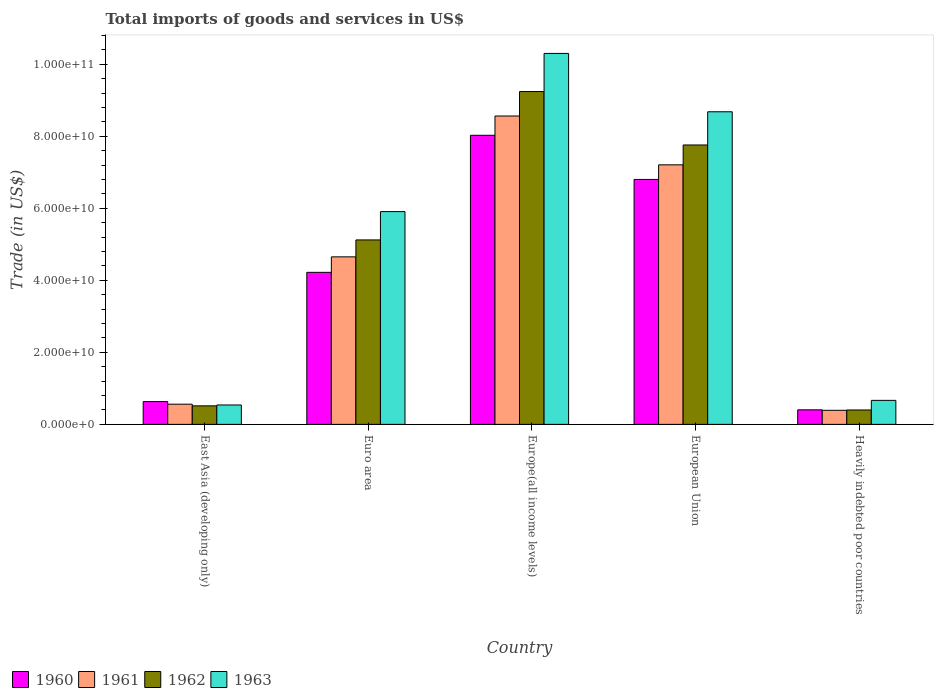How many different coloured bars are there?
Provide a short and direct response. 4. How many bars are there on the 2nd tick from the left?
Keep it short and to the point. 4. How many bars are there on the 5th tick from the right?
Offer a very short reply. 4. In how many cases, is the number of bars for a given country not equal to the number of legend labels?
Give a very brief answer. 0. What is the total imports of goods and services in 1961 in European Union?
Your answer should be very brief. 7.21e+1. Across all countries, what is the maximum total imports of goods and services in 1960?
Keep it short and to the point. 8.03e+1. Across all countries, what is the minimum total imports of goods and services in 1962?
Offer a very short reply. 4.00e+09. In which country was the total imports of goods and services in 1962 maximum?
Provide a short and direct response. Europe(all income levels). In which country was the total imports of goods and services in 1960 minimum?
Offer a terse response. Heavily indebted poor countries. What is the total total imports of goods and services in 1963 in the graph?
Ensure brevity in your answer.  2.61e+11. What is the difference between the total imports of goods and services in 1963 in East Asia (developing only) and that in Europe(all income levels)?
Your answer should be compact. -9.76e+1. What is the difference between the total imports of goods and services in 1962 in Euro area and the total imports of goods and services in 1961 in Heavily indebted poor countries?
Offer a very short reply. 4.73e+1. What is the average total imports of goods and services in 1961 per country?
Your response must be concise. 4.27e+1. What is the difference between the total imports of goods and services of/in 1960 and total imports of goods and services of/in 1961 in European Union?
Your response must be concise. -4.05e+09. What is the ratio of the total imports of goods and services in 1961 in East Asia (developing only) to that in European Union?
Provide a short and direct response. 0.08. Is the difference between the total imports of goods and services in 1960 in Europe(all income levels) and Heavily indebted poor countries greater than the difference between the total imports of goods and services in 1961 in Europe(all income levels) and Heavily indebted poor countries?
Your answer should be very brief. No. What is the difference between the highest and the second highest total imports of goods and services in 1963?
Provide a succinct answer. -1.62e+1. What is the difference between the highest and the lowest total imports of goods and services in 1963?
Give a very brief answer. 9.76e+1. Is the sum of the total imports of goods and services in 1962 in European Union and Heavily indebted poor countries greater than the maximum total imports of goods and services in 1963 across all countries?
Your response must be concise. No. What does the 2nd bar from the left in Europe(all income levels) represents?
Give a very brief answer. 1961. What does the 2nd bar from the right in European Union represents?
Your response must be concise. 1962. How many bars are there?
Give a very brief answer. 20. Are all the bars in the graph horizontal?
Give a very brief answer. No. How many countries are there in the graph?
Offer a very short reply. 5. What is the difference between two consecutive major ticks on the Y-axis?
Offer a very short reply. 2.00e+1. Does the graph contain any zero values?
Your answer should be compact. No. Does the graph contain grids?
Offer a very short reply. No. How many legend labels are there?
Your answer should be very brief. 4. How are the legend labels stacked?
Your answer should be very brief. Horizontal. What is the title of the graph?
Your response must be concise. Total imports of goods and services in US$. Does "1979" appear as one of the legend labels in the graph?
Provide a short and direct response. No. What is the label or title of the X-axis?
Your response must be concise. Country. What is the label or title of the Y-axis?
Your answer should be very brief. Trade (in US$). What is the Trade (in US$) of 1960 in East Asia (developing only)?
Make the answer very short. 6.33e+09. What is the Trade (in US$) of 1961 in East Asia (developing only)?
Provide a short and direct response. 5.60e+09. What is the Trade (in US$) in 1962 in East Asia (developing only)?
Offer a very short reply. 5.14e+09. What is the Trade (in US$) of 1963 in East Asia (developing only)?
Ensure brevity in your answer.  5.39e+09. What is the Trade (in US$) of 1960 in Euro area?
Offer a very short reply. 4.22e+1. What is the Trade (in US$) in 1961 in Euro area?
Keep it short and to the point. 4.65e+1. What is the Trade (in US$) in 1962 in Euro area?
Offer a very short reply. 5.12e+1. What is the Trade (in US$) of 1963 in Euro area?
Offer a terse response. 5.91e+1. What is the Trade (in US$) of 1960 in Europe(all income levels)?
Offer a very short reply. 8.03e+1. What is the Trade (in US$) in 1961 in Europe(all income levels)?
Ensure brevity in your answer.  8.56e+1. What is the Trade (in US$) of 1962 in Europe(all income levels)?
Offer a terse response. 9.24e+1. What is the Trade (in US$) of 1963 in Europe(all income levels)?
Offer a terse response. 1.03e+11. What is the Trade (in US$) in 1960 in European Union?
Your response must be concise. 6.80e+1. What is the Trade (in US$) of 1961 in European Union?
Provide a succinct answer. 7.21e+1. What is the Trade (in US$) of 1962 in European Union?
Give a very brief answer. 7.76e+1. What is the Trade (in US$) in 1963 in European Union?
Your answer should be very brief. 8.68e+1. What is the Trade (in US$) of 1960 in Heavily indebted poor countries?
Give a very brief answer. 4.04e+09. What is the Trade (in US$) of 1961 in Heavily indebted poor countries?
Offer a very short reply. 3.91e+09. What is the Trade (in US$) of 1962 in Heavily indebted poor countries?
Your answer should be compact. 4.00e+09. What is the Trade (in US$) in 1963 in Heavily indebted poor countries?
Make the answer very short. 6.67e+09. Across all countries, what is the maximum Trade (in US$) of 1960?
Offer a very short reply. 8.03e+1. Across all countries, what is the maximum Trade (in US$) of 1961?
Give a very brief answer. 8.56e+1. Across all countries, what is the maximum Trade (in US$) of 1962?
Ensure brevity in your answer.  9.24e+1. Across all countries, what is the maximum Trade (in US$) in 1963?
Your answer should be very brief. 1.03e+11. Across all countries, what is the minimum Trade (in US$) in 1960?
Your answer should be very brief. 4.04e+09. Across all countries, what is the minimum Trade (in US$) of 1961?
Ensure brevity in your answer.  3.91e+09. Across all countries, what is the minimum Trade (in US$) in 1962?
Provide a short and direct response. 4.00e+09. Across all countries, what is the minimum Trade (in US$) of 1963?
Provide a succinct answer. 5.39e+09. What is the total Trade (in US$) in 1960 in the graph?
Offer a terse response. 2.01e+11. What is the total Trade (in US$) in 1961 in the graph?
Keep it short and to the point. 2.14e+11. What is the total Trade (in US$) in 1962 in the graph?
Provide a short and direct response. 2.30e+11. What is the total Trade (in US$) in 1963 in the graph?
Provide a short and direct response. 2.61e+11. What is the difference between the Trade (in US$) of 1960 in East Asia (developing only) and that in Euro area?
Offer a terse response. -3.59e+1. What is the difference between the Trade (in US$) in 1961 in East Asia (developing only) and that in Euro area?
Make the answer very short. -4.09e+1. What is the difference between the Trade (in US$) in 1962 in East Asia (developing only) and that in Euro area?
Your answer should be very brief. -4.61e+1. What is the difference between the Trade (in US$) of 1963 in East Asia (developing only) and that in Euro area?
Your response must be concise. -5.37e+1. What is the difference between the Trade (in US$) in 1960 in East Asia (developing only) and that in Europe(all income levels)?
Your answer should be very brief. -7.39e+1. What is the difference between the Trade (in US$) in 1961 in East Asia (developing only) and that in Europe(all income levels)?
Offer a very short reply. -8.00e+1. What is the difference between the Trade (in US$) in 1962 in East Asia (developing only) and that in Europe(all income levels)?
Your answer should be very brief. -8.73e+1. What is the difference between the Trade (in US$) of 1963 in East Asia (developing only) and that in Europe(all income levels)?
Your answer should be very brief. -9.76e+1. What is the difference between the Trade (in US$) of 1960 in East Asia (developing only) and that in European Union?
Your answer should be compact. -6.17e+1. What is the difference between the Trade (in US$) of 1961 in East Asia (developing only) and that in European Union?
Provide a succinct answer. -6.65e+1. What is the difference between the Trade (in US$) in 1962 in East Asia (developing only) and that in European Union?
Offer a very short reply. -7.24e+1. What is the difference between the Trade (in US$) of 1963 in East Asia (developing only) and that in European Union?
Your answer should be very brief. -8.14e+1. What is the difference between the Trade (in US$) in 1960 in East Asia (developing only) and that in Heavily indebted poor countries?
Give a very brief answer. 2.29e+09. What is the difference between the Trade (in US$) of 1961 in East Asia (developing only) and that in Heavily indebted poor countries?
Provide a short and direct response. 1.70e+09. What is the difference between the Trade (in US$) of 1962 in East Asia (developing only) and that in Heavily indebted poor countries?
Offer a terse response. 1.14e+09. What is the difference between the Trade (in US$) of 1963 in East Asia (developing only) and that in Heavily indebted poor countries?
Keep it short and to the point. -1.28e+09. What is the difference between the Trade (in US$) of 1960 in Euro area and that in Europe(all income levels)?
Keep it short and to the point. -3.80e+1. What is the difference between the Trade (in US$) in 1961 in Euro area and that in Europe(all income levels)?
Provide a short and direct response. -3.91e+1. What is the difference between the Trade (in US$) in 1962 in Euro area and that in Europe(all income levels)?
Your response must be concise. -4.12e+1. What is the difference between the Trade (in US$) of 1963 in Euro area and that in Europe(all income levels)?
Offer a terse response. -4.39e+1. What is the difference between the Trade (in US$) in 1960 in Euro area and that in European Union?
Offer a terse response. -2.58e+1. What is the difference between the Trade (in US$) of 1961 in Euro area and that in European Union?
Provide a succinct answer. -2.56e+1. What is the difference between the Trade (in US$) in 1962 in Euro area and that in European Union?
Provide a short and direct response. -2.64e+1. What is the difference between the Trade (in US$) in 1963 in Euro area and that in European Union?
Offer a very short reply. -2.77e+1. What is the difference between the Trade (in US$) in 1960 in Euro area and that in Heavily indebted poor countries?
Offer a very short reply. 3.82e+1. What is the difference between the Trade (in US$) of 1961 in Euro area and that in Heavily indebted poor countries?
Your response must be concise. 4.26e+1. What is the difference between the Trade (in US$) in 1962 in Euro area and that in Heavily indebted poor countries?
Your answer should be very brief. 4.72e+1. What is the difference between the Trade (in US$) in 1963 in Euro area and that in Heavily indebted poor countries?
Offer a terse response. 5.24e+1. What is the difference between the Trade (in US$) in 1960 in Europe(all income levels) and that in European Union?
Ensure brevity in your answer.  1.23e+1. What is the difference between the Trade (in US$) in 1961 in Europe(all income levels) and that in European Union?
Your response must be concise. 1.36e+1. What is the difference between the Trade (in US$) of 1962 in Europe(all income levels) and that in European Union?
Provide a short and direct response. 1.48e+1. What is the difference between the Trade (in US$) in 1963 in Europe(all income levels) and that in European Union?
Offer a very short reply. 1.62e+1. What is the difference between the Trade (in US$) of 1960 in Europe(all income levels) and that in Heavily indebted poor countries?
Provide a short and direct response. 7.62e+1. What is the difference between the Trade (in US$) of 1961 in Europe(all income levels) and that in Heavily indebted poor countries?
Provide a succinct answer. 8.17e+1. What is the difference between the Trade (in US$) of 1962 in Europe(all income levels) and that in Heavily indebted poor countries?
Your answer should be compact. 8.84e+1. What is the difference between the Trade (in US$) of 1963 in Europe(all income levels) and that in Heavily indebted poor countries?
Ensure brevity in your answer.  9.63e+1. What is the difference between the Trade (in US$) of 1960 in European Union and that in Heavily indebted poor countries?
Give a very brief answer. 6.40e+1. What is the difference between the Trade (in US$) of 1961 in European Union and that in Heavily indebted poor countries?
Your response must be concise. 6.82e+1. What is the difference between the Trade (in US$) in 1962 in European Union and that in Heavily indebted poor countries?
Provide a succinct answer. 7.36e+1. What is the difference between the Trade (in US$) in 1963 in European Union and that in Heavily indebted poor countries?
Make the answer very short. 8.01e+1. What is the difference between the Trade (in US$) of 1960 in East Asia (developing only) and the Trade (in US$) of 1961 in Euro area?
Provide a short and direct response. -4.02e+1. What is the difference between the Trade (in US$) of 1960 in East Asia (developing only) and the Trade (in US$) of 1962 in Euro area?
Ensure brevity in your answer.  -4.49e+1. What is the difference between the Trade (in US$) of 1960 in East Asia (developing only) and the Trade (in US$) of 1963 in Euro area?
Your answer should be compact. -5.27e+1. What is the difference between the Trade (in US$) of 1961 in East Asia (developing only) and the Trade (in US$) of 1962 in Euro area?
Provide a short and direct response. -4.56e+1. What is the difference between the Trade (in US$) in 1961 in East Asia (developing only) and the Trade (in US$) in 1963 in Euro area?
Offer a terse response. -5.35e+1. What is the difference between the Trade (in US$) in 1962 in East Asia (developing only) and the Trade (in US$) in 1963 in Euro area?
Ensure brevity in your answer.  -5.39e+1. What is the difference between the Trade (in US$) in 1960 in East Asia (developing only) and the Trade (in US$) in 1961 in Europe(all income levels)?
Offer a very short reply. -7.93e+1. What is the difference between the Trade (in US$) of 1960 in East Asia (developing only) and the Trade (in US$) of 1962 in Europe(all income levels)?
Ensure brevity in your answer.  -8.61e+1. What is the difference between the Trade (in US$) of 1960 in East Asia (developing only) and the Trade (in US$) of 1963 in Europe(all income levels)?
Your answer should be compact. -9.67e+1. What is the difference between the Trade (in US$) of 1961 in East Asia (developing only) and the Trade (in US$) of 1962 in Europe(all income levels)?
Your answer should be very brief. -8.68e+1. What is the difference between the Trade (in US$) of 1961 in East Asia (developing only) and the Trade (in US$) of 1963 in Europe(all income levels)?
Offer a terse response. -9.74e+1. What is the difference between the Trade (in US$) of 1962 in East Asia (developing only) and the Trade (in US$) of 1963 in Europe(all income levels)?
Your response must be concise. -9.79e+1. What is the difference between the Trade (in US$) in 1960 in East Asia (developing only) and the Trade (in US$) in 1961 in European Union?
Keep it short and to the point. -6.57e+1. What is the difference between the Trade (in US$) of 1960 in East Asia (developing only) and the Trade (in US$) of 1962 in European Union?
Provide a succinct answer. -7.12e+1. What is the difference between the Trade (in US$) in 1960 in East Asia (developing only) and the Trade (in US$) in 1963 in European Union?
Give a very brief answer. -8.05e+1. What is the difference between the Trade (in US$) of 1961 in East Asia (developing only) and the Trade (in US$) of 1962 in European Union?
Make the answer very short. -7.20e+1. What is the difference between the Trade (in US$) of 1961 in East Asia (developing only) and the Trade (in US$) of 1963 in European Union?
Your answer should be very brief. -8.12e+1. What is the difference between the Trade (in US$) of 1962 in East Asia (developing only) and the Trade (in US$) of 1963 in European Union?
Provide a short and direct response. -8.17e+1. What is the difference between the Trade (in US$) in 1960 in East Asia (developing only) and the Trade (in US$) in 1961 in Heavily indebted poor countries?
Your answer should be compact. 2.42e+09. What is the difference between the Trade (in US$) in 1960 in East Asia (developing only) and the Trade (in US$) in 1962 in Heavily indebted poor countries?
Make the answer very short. 2.33e+09. What is the difference between the Trade (in US$) of 1960 in East Asia (developing only) and the Trade (in US$) of 1963 in Heavily indebted poor countries?
Provide a short and direct response. -3.39e+08. What is the difference between the Trade (in US$) of 1961 in East Asia (developing only) and the Trade (in US$) of 1962 in Heavily indebted poor countries?
Provide a short and direct response. 1.61e+09. What is the difference between the Trade (in US$) in 1961 in East Asia (developing only) and the Trade (in US$) in 1963 in Heavily indebted poor countries?
Provide a succinct answer. -1.06e+09. What is the difference between the Trade (in US$) of 1962 in East Asia (developing only) and the Trade (in US$) of 1963 in Heavily indebted poor countries?
Make the answer very short. -1.53e+09. What is the difference between the Trade (in US$) in 1960 in Euro area and the Trade (in US$) in 1961 in Europe(all income levels)?
Make the answer very short. -4.34e+1. What is the difference between the Trade (in US$) of 1960 in Euro area and the Trade (in US$) of 1962 in Europe(all income levels)?
Your response must be concise. -5.02e+1. What is the difference between the Trade (in US$) in 1960 in Euro area and the Trade (in US$) in 1963 in Europe(all income levels)?
Provide a short and direct response. -6.08e+1. What is the difference between the Trade (in US$) in 1961 in Euro area and the Trade (in US$) in 1962 in Europe(all income levels)?
Your answer should be very brief. -4.59e+1. What is the difference between the Trade (in US$) in 1961 in Euro area and the Trade (in US$) in 1963 in Europe(all income levels)?
Provide a short and direct response. -5.65e+1. What is the difference between the Trade (in US$) of 1962 in Euro area and the Trade (in US$) of 1963 in Europe(all income levels)?
Keep it short and to the point. -5.18e+1. What is the difference between the Trade (in US$) of 1960 in Euro area and the Trade (in US$) of 1961 in European Union?
Provide a short and direct response. -2.98e+1. What is the difference between the Trade (in US$) in 1960 in Euro area and the Trade (in US$) in 1962 in European Union?
Provide a succinct answer. -3.54e+1. What is the difference between the Trade (in US$) of 1960 in Euro area and the Trade (in US$) of 1963 in European Union?
Make the answer very short. -4.46e+1. What is the difference between the Trade (in US$) of 1961 in Euro area and the Trade (in US$) of 1962 in European Union?
Provide a short and direct response. -3.11e+1. What is the difference between the Trade (in US$) in 1961 in Euro area and the Trade (in US$) in 1963 in European Union?
Your response must be concise. -4.03e+1. What is the difference between the Trade (in US$) in 1962 in Euro area and the Trade (in US$) in 1963 in European Union?
Your response must be concise. -3.56e+1. What is the difference between the Trade (in US$) of 1960 in Euro area and the Trade (in US$) of 1961 in Heavily indebted poor countries?
Provide a succinct answer. 3.83e+1. What is the difference between the Trade (in US$) of 1960 in Euro area and the Trade (in US$) of 1962 in Heavily indebted poor countries?
Your answer should be compact. 3.82e+1. What is the difference between the Trade (in US$) in 1960 in Euro area and the Trade (in US$) in 1963 in Heavily indebted poor countries?
Make the answer very short. 3.55e+1. What is the difference between the Trade (in US$) of 1961 in Euro area and the Trade (in US$) of 1962 in Heavily indebted poor countries?
Offer a very short reply. 4.25e+1. What is the difference between the Trade (in US$) in 1961 in Euro area and the Trade (in US$) in 1963 in Heavily indebted poor countries?
Give a very brief answer. 3.98e+1. What is the difference between the Trade (in US$) in 1962 in Euro area and the Trade (in US$) in 1963 in Heavily indebted poor countries?
Ensure brevity in your answer.  4.45e+1. What is the difference between the Trade (in US$) of 1960 in Europe(all income levels) and the Trade (in US$) of 1961 in European Union?
Your answer should be very brief. 8.20e+09. What is the difference between the Trade (in US$) of 1960 in Europe(all income levels) and the Trade (in US$) of 1962 in European Union?
Provide a succinct answer. 2.69e+09. What is the difference between the Trade (in US$) in 1960 in Europe(all income levels) and the Trade (in US$) in 1963 in European Union?
Provide a short and direct response. -6.53e+09. What is the difference between the Trade (in US$) in 1961 in Europe(all income levels) and the Trade (in US$) in 1962 in European Union?
Your answer should be very brief. 8.04e+09. What is the difference between the Trade (in US$) of 1961 in Europe(all income levels) and the Trade (in US$) of 1963 in European Union?
Offer a terse response. -1.18e+09. What is the difference between the Trade (in US$) in 1962 in Europe(all income levels) and the Trade (in US$) in 1963 in European Union?
Your response must be concise. 5.61e+09. What is the difference between the Trade (in US$) in 1960 in Europe(all income levels) and the Trade (in US$) in 1961 in Heavily indebted poor countries?
Keep it short and to the point. 7.64e+1. What is the difference between the Trade (in US$) of 1960 in Europe(all income levels) and the Trade (in US$) of 1962 in Heavily indebted poor countries?
Your answer should be compact. 7.63e+1. What is the difference between the Trade (in US$) of 1960 in Europe(all income levels) and the Trade (in US$) of 1963 in Heavily indebted poor countries?
Provide a short and direct response. 7.36e+1. What is the difference between the Trade (in US$) in 1961 in Europe(all income levels) and the Trade (in US$) in 1962 in Heavily indebted poor countries?
Offer a terse response. 8.16e+1. What is the difference between the Trade (in US$) in 1961 in Europe(all income levels) and the Trade (in US$) in 1963 in Heavily indebted poor countries?
Your answer should be compact. 7.90e+1. What is the difference between the Trade (in US$) of 1962 in Europe(all income levels) and the Trade (in US$) of 1963 in Heavily indebted poor countries?
Your answer should be very brief. 8.57e+1. What is the difference between the Trade (in US$) of 1960 in European Union and the Trade (in US$) of 1961 in Heavily indebted poor countries?
Your response must be concise. 6.41e+1. What is the difference between the Trade (in US$) in 1960 in European Union and the Trade (in US$) in 1962 in Heavily indebted poor countries?
Keep it short and to the point. 6.40e+1. What is the difference between the Trade (in US$) in 1960 in European Union and the Trade (in US$) in 1963 in Heavily indebted poor countries?
Your answer should be compact. 6.13e+1. What is the difference between the Trade (in US$) of 1961 in European Union and the Trade (in US$) of 1962 in Heavily indebted poor countries?
Offer a very short reply. 6.81e+1. What is the difference between the Trade (in US$) in 1961 in European Union and the Trade (in US$) in 1963 in Heavily indebted poor countries?
Your answer should be compact. 6.54e+1. What is the difference between the Trade (in US$) in 1962 in European Union and the Trade (in US$) in 1963 in Heavily indebted poor countries?
Provide a succinct answer. 7.09e+1. What is the average Trade (in US$) of 1960 per country?
Provide a succinct answer. 4.02e+1. What is the average Trade (in US$) of 1961 per country?
Keep it short and to the point. 4.27e+1. What is the average Trade (in US$) in 1962 per country?
Your answer should be compact. 4.61e+1. What is the average Trade (in US$) in 1963 per country?
Provide a succinct answer. 5.22e+1. What is the difference between the Trade (in US$) in 1960 and Trade (in US$) in 1961 in East Asia (developing only)?
Your response must be concise. 7.24e+08. What is the difference between the Trade (in US$) of 1960 and Trade (in US$) of 1962 in East Asia (developing only)?
Keep it short and to the point. 1.19e+09. What is the difference between the Trade (in US$) in 1960 and Trade (in US$) in 1963 in East Asia (developing only)?
Your response must be concise. 9.42e+08. What is the difference between the Trade (in US$) of 1961 and Trade (in US$) of 1962 in East Asia (developing only)?
Offer a very short reply. 4.63e+08. What is the difference between the Trade (in US$) of 1961 and Trade (in US$) of 1963 in East Asia (developing only)?
Give a very brief answer. 2.18e+08. What is the difference between the Trade (in US$) in 1962 and Trade (in US$) in 1963 in East Asia (developing only)?
Give a very brief answer. -2.45e+08. What is the difference between the Trade (in US$) of 1960 and Trade (in US$) of 1961 in Euro area?
Offer a very short reply. -4.30e+09. What is the difference between the Trade (in US$) in 1960 and Trade (in US$) in 1962 in Euro area?
Your response must be concise. -9.00e+09. What is the difference between the Trade (in US$) in 1960 and Trade (in US$) in 1963 in Euro area?
Your answer should be compact. -1.69e+1. What is the difference between the Trade (in US$) of 1961 and Trade (in US$) of 1962 in Euro area?
Offer a very short reply. -4.70e+09. What is the difference between the Trade (in US$) of 1961 and Trade (in US$) of 1963 in Euro area?
Your answer should be very brief. -1.26e+1. What is the difference between the Trade (in US$) of 1962 and Trade (in US$) of 1963 in Euro area?
Provide a succinct answer. -7.86e+09. What is the difference between the Trade (in US$) in 1960 and Trade (in US$) in 1961 in Europe(all income levels)?
Provide a succinct answer. -5.35e+09. What is the difference between the Trade (in US$) of 1960 and Trade (in US$) of 1962 in Europe(all income levels)?
Your answer should be compact. -1.21e+1. What is the difference between the Trade (in US$) in 1960 and Trade (in US$) in 1963 in Europe(all income levels)?
Your answer should be compact. -2.27e+1. What is the difference between the Trade (in US$) in 1961 and Trade (in US$) in 1962 in Europe(all income levels)?
Give a very brief answer. -6.79e+09. What is the difference between the Trade (in US$) of 1961 and Trade (in US$) of 1963 in Europe(all income levels)?
Provide a succinct answer. -1.74e+1. What is the difference between the Trade (in US$) of 1962 and Trade (in US$) of 1963 in Europe(all income levels)?
Give a very brief answer. -1.06e+1. What is the difference between the Trade (in US$) in 1960 and Trade (in US$) in 1961 in European Union?
Your answer should be compact. -4.05e+09. What is the difference between the Trade (in US$) of 1960 and Trade (in US$) of 1962 in European Union?
Offer a terse response. -9.57e+09. What is the difference between the Trade (in US$) of 1960 and Trade (in US$) of 1963 in European Union?
Keep it short and to the point. -1.88e+1. What is the difference between the Trade (in US$) in 1961 and Trade (in US$) in 1962 in European Union?
Keep it short and to the point. -5.51e+09. What is the difference between the Trade (in US$) in 1961 and Trade (in US$) in 1963 in European Union?
Offer a very short reply. -1.47e+1. What is the difference between the Trade (in US$) in 1962 and Trade (in US$) in 1963 in European Union?
Provide a short and direct response. -9.22e+09. What is the difference between the Trade (in US$) of 1960 and Trade (in US$) of 1961 in Heavily indebted poor countries?
Provide a succinct answer. 1.30e+08. What is the difference between the Trade (in US$) of 1960 and Trade (in US$) of 1962 in Heavily indebted poor countries?
Give a very brief answer. 3.87e+07. What is the difference between the Trade (in US$) of 1960 and Trade (in US$) of 1963 in Heavily indebted poor countries?
Your answer should be very brief. -2.63e+09. What is the difference between the Trade (in US$) of 1961 and Trade (in US$) of 1962 in Heavily indebted poor countries?
Give a very brief answer. -9.18e+07. What is the difference between the Trade (in US$) of 1961 and Trade (in US$) of 1963 in Heavily indebted poor countries?
Make the answer very short. -2.76e+09. What is the difference between the Trade (in US$) of 1962 and Trade (in US$) of 1963 in Heavily indebted poor countries?
Your response must be concise. -2.67e+09. What is the ratio of the Trade (in US$) in 1960 in East Asia (developing only) to that in Euro area?
Your answer should be compact. 0.15. What is the ratio of the Trade (in US$) of 1961 in East Asia (developing only) to that in Euro area?
Offer a terse response. 0.12. What is the ratio of the Trade (in US$) in 1962 in East Asia (developing only) to that in Euro area?
Your answer should be compact. 0.1. What is the ratio of the Trade (in US$) in 1963 in East Asia (developing only) to that in Euro area?
Offer a very short reply. 0.09. What is the ratio of the Trade (in US$) of 1960 in East Asia (developing only) to that in Europe(all income levels)?
Your response must be concise. 0.08. What is the ratio of the Trade (in US$) in 1961 in East Asia (developing only) to that in Europe(all income levels)?
Your response must be concise. 0.07. What is the ratio of the Trade (in US$) in 1962 in East Asia (developing only) to that in Europe(all income levels)?
Your response must be concise. 0.06. What is the ratio of the Trade (in US$) in 1963 in East Asia (developing only) to that in Europe(all income levels)?
Ensure brevity in your answer.  0.05. What is the ratio of the Trade (in US$) in 1960 in East Asia (developing only) to that in European Union?
Make the answer very short. 0.09. What is the ratio of the Trade (in US$) of 1961 in East Asia (developing only) to that in European Union?
Give a very brief answer. 0.08. What is the ratio of the Trade (in US$) of 1962 in East Asia (developing only) to that in European Union?
Offer a terse response. 0.07. What is the ratio of the Trade (in US$) of 1963 in East Asia (developing only) to that in European Union?
Your answer should be very brief. 0.06. What is the ratio of the Trade (in US$) in 1960 in East Asia (developing only) to that in Heavily indebted poor countries?
Your answer should be compact. 1.57. What is the ratio of the Trade (in US$) of 1961 in East Asia (developing only) to that in Heavily indebted poor countries?
Ensure brevity in your answer.  1.43. What is the ratio of the Trade (in US$) in 1962 in East Asia (developing only) to that in Heavily indebted poor countries?
Make the answer very short. 1.29. What is the ratio of the Trade (in US$) in 1963 in East Asia (developing only) to that in Heavily indebted poor countries?
Provide a short and direct response. 0.81. What is the ratio of the Trade (in US$) of 1960 in Euro area to that in Europe(all income levels)?
Ensure brevity in your answer.  0.53. What is the ratio of the Trade (in US$) in 1961 in Euro area to that in Europe(all income levels)?
Give a very brief answer. 0.54. What is the ratio of the Trade (in US$) of 1962 in Euro area to that in Europe(all income levels)?
Offer a very short reply. 0.55. What is the ratio of the Trade (in US$) of 1963 in Euro area to that in Europe(all income levels)?
Give a very brief answer. 0.57. What is the ratio of the Trade (in US$) in 1960 in Euro area to that in European Union?
Offer a terse response. 0.62. What is the ratio of the Trade (in US$) of 1961 in Euro area to that in European Union?
Give a very brief answer. 0.65. What is the ratio of the Trade (in US$) in 1962 in Euro area to that in European Union?
Provide a succinct answer. 0.66. What is the ratio of the Trade (in US$) of 1963 in Euro area to that in European Union?
Offer a very short reply. 0.68. What is the ratio of the Trade (in US$) of 1960 in Euro area to that in Heavily indebted poor countries?
Your answer should be very brief. 10.45. What is the ratio of the Trade (in US$) in 1961 in Euro area to that in Heavily indebted poor countries?
Provide a short and direct response. 11.9. What is the ratio of the Trade (in US$) of 1962 in Euro area to that in Heavily indebted poor countries?
Ensure brevity in your answer.  12.81. What is the ratio of the Trade (in US$) of 1963 in Euro area to that in Heavily indebted poor countries?
Make the answer very short. 8.86. What is the ratio of the Trade (in US$) in 1960 in Europe(all income levels) to that in European Union?
Offer a terse response. 1.18. What is the ratio of the Trade (in US$) of 1961 in Europe(all income levels) to that in European Union?
Your answer should be very brief. 1.19. What is the ratio of the Trade (in US$) in 1962 in Europe(all income levels) to that in European Union?
Offer a very short reply. 1.19. What is the ratio of the Trade (in US$) of 1963 in Europe(all income levels) to that in European Union?
Offer a terse response. 1.19. What is the ratio of the Trade (in US$) of 1960 in Europe(all income levels) to that in Heavily indebted poor countries?
Provide a succinct answer. 19.88. What is the ratio of the Trade (in US$) in 1961 in Europe(all income levels) to that in Heavily indebted poor countries?
Offer a very short reply. 21.91. What is the ratio of the Trade (in US$) of 1962 in Europe(all income levels) to that in Heavily indebted poor countries?
Provide a short and direct response. 23.11. What is the ratio of the Trade (in US$) in 1963 in Europe(all income levels) to that in Heavily indebted poor countries?
Keep it short and to the point. 15.45. What is the ratio of the Trade (in US$) in 1960 in European Union to that in Heavily indebted poor countries?
Offer a very short reply. 16.84. What is the ratio of the Trade (in US$) of 1961 in European Union to that in Heavily indebted poor countries?
Ensure brevity in your answer.  18.44. What is the ratio of the Trade (in US$) of 1962 in European Union to that in Heavily indebted poor countries?
Provide a succinct answer. 19.4. What is the ratio of the Trade (in US$) of 1963 in European Union to that in Heavily indebted poor countries?
Ensure brevity in your answer.  13.02. What is the difference between the highest and the second highest Trade (in US$) in 1960?
Provide a short and direct response. 1.23e+1. What is the difference between the highest and the second highest Trade (in US$) of 1961?
Make the answer very short. 1.36e+1. What is the difference between the highest and the second highest Trade (in US$) in 1962?
Offer a very short reply. 1.48e+1. What is the difference between the highest and the second highest Trade (in US$) in 1963?
Make the answer very short. 1.62e+1. What is the difference between the highest and the lowest Trade (in US$) of 1960?
Ensure brevity in your answer.  7.62e+1. What is the difference between the highest and the lowest Trade (in US$) of 1961?
Your response must be concise. 8.17e+1. What is the difference between the highest and the lowest Trade (in US$) in 1962?
Make the answer very short. 8.84e+1. What is the difference between the highest and the lowest Trade (in US$) of 1963?
Keep it short and to the point. 9.76e+1. 